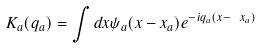<formula> <loc_0><loc_0><loc_500><loc_500>K _ { a } ( { q } _ { a } ) = \int d { x } \psi _ { a } ( { x } - { x } _ { a } ) e ^ { - i { q } _ { a } ( { x } - \ x _ { a } ) }</formula> 